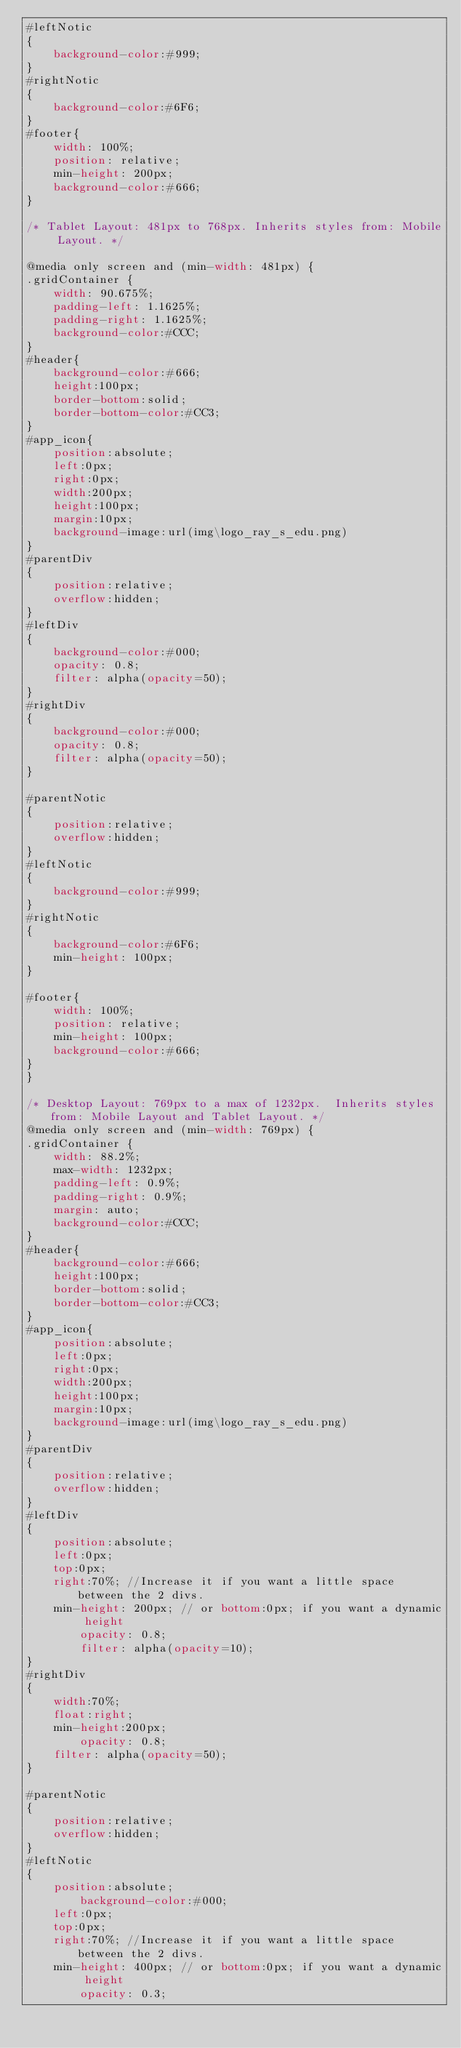<code> <loc_0><loc_0><loc_500><loc_500><_CSS_>#leftNotic
{
	background-color:#999;
}
#rightNotic
{
	background-color:#6F6;
}
#footer{
	width: 100%;
	position: relative;
	min-height: 200px;
	background-color:#666;
}

/* Tablet Layout: 481px to 768px. Inherits styles from: Mobile Layout. */

@media only screen and (min-width: 481px) {
.gridContainer {
	width: 90.675%;
	padding-left: 1.1625%;
	padding-right: 1.1625%;
	background-color:#CCC;
}
#header{
	background-color:#666;
	height:100px;
	border-bottom:solid;
	border-bottom-color:#CC3;
}
#app_icon{
	position:absolute;
	left:0px;
	right:0px;
	width:200px;
	height:100px;
	margin:10px;
	background-image:url(img\logo_ray_s_edu.png)
}
#parentDiv
{
    position:relative;
    overflow:hidden;
}
#leftDiv
{
	background-color:#000;
	opacity: 0.8;
    filter: alpha(opacity=50);
}
#rightDiv
{
	background-color:#000;
	opacity: 0.8;
    filter: alpha(opacity=50);
}

#parentNotic
{
    position:relative;
    overflow:hidden;
}
#leftNotic
{
	background-color:#999;
}
#rightNotic
{
	background-color:#6F6;
	min-height: 100px;
}

#footer{
	width: 100%;
	position: relative;
	min-height: 100px;
	background-color:#666;
}
}

/* Desktop Layout: 769px to a max of 1232px.  Inherits styles from: Mobile Layout and Tablet Layout. */
@media only screen and (min-width: 769px) {
.gridContainer {
	width: 88.2%;
	max-width: 1232px;
	padding-left: 0.9%;
	padding-right: 0.9%;
	margin: auto;
	background-color:#CCC;
}
#header{
	background-color:#666;
	height:100px;
	border-bottom:solid;
	border-bottom-color:#CC3;
}
#app_icon{
	position:absolute;
	left:0px;
	right:0px;
	width:200px;
	height:100px;
	margin:10px;
	background-image:url(img\logo_ray_s_edu.png)
}
#parentDiv
{
    position:relative;
    overflow:hidden;
}
#leftDiv
{
    position:absolute;
    left:0px;
    top:0px;
    right:70%; //Increase it if you want a little space between the 2 divs.
    min-height: 200px; // or bottom:0px; if you want a dynamic height
		opacity: 0.8;
		filter: alpha(opacity=10);
}
#rightDiv
{
    width:70%;
    float:right;
    min-height:200px;
		opacity: 0.8;
    filter: alpha(opacity=50);
}

#parentNotic
{
    position:relative;
    overflow:hidden;
}
#leftNotic
{
    position:absolute;
		background-color:#000;
    left:0px;
    top:0px;
    right:70%; //Increase it if you want a little space between the 2 divs.
    min-height: 400px; // or bottom:0px; if you want a dynamic height
		opacity: 0.3;</code> 